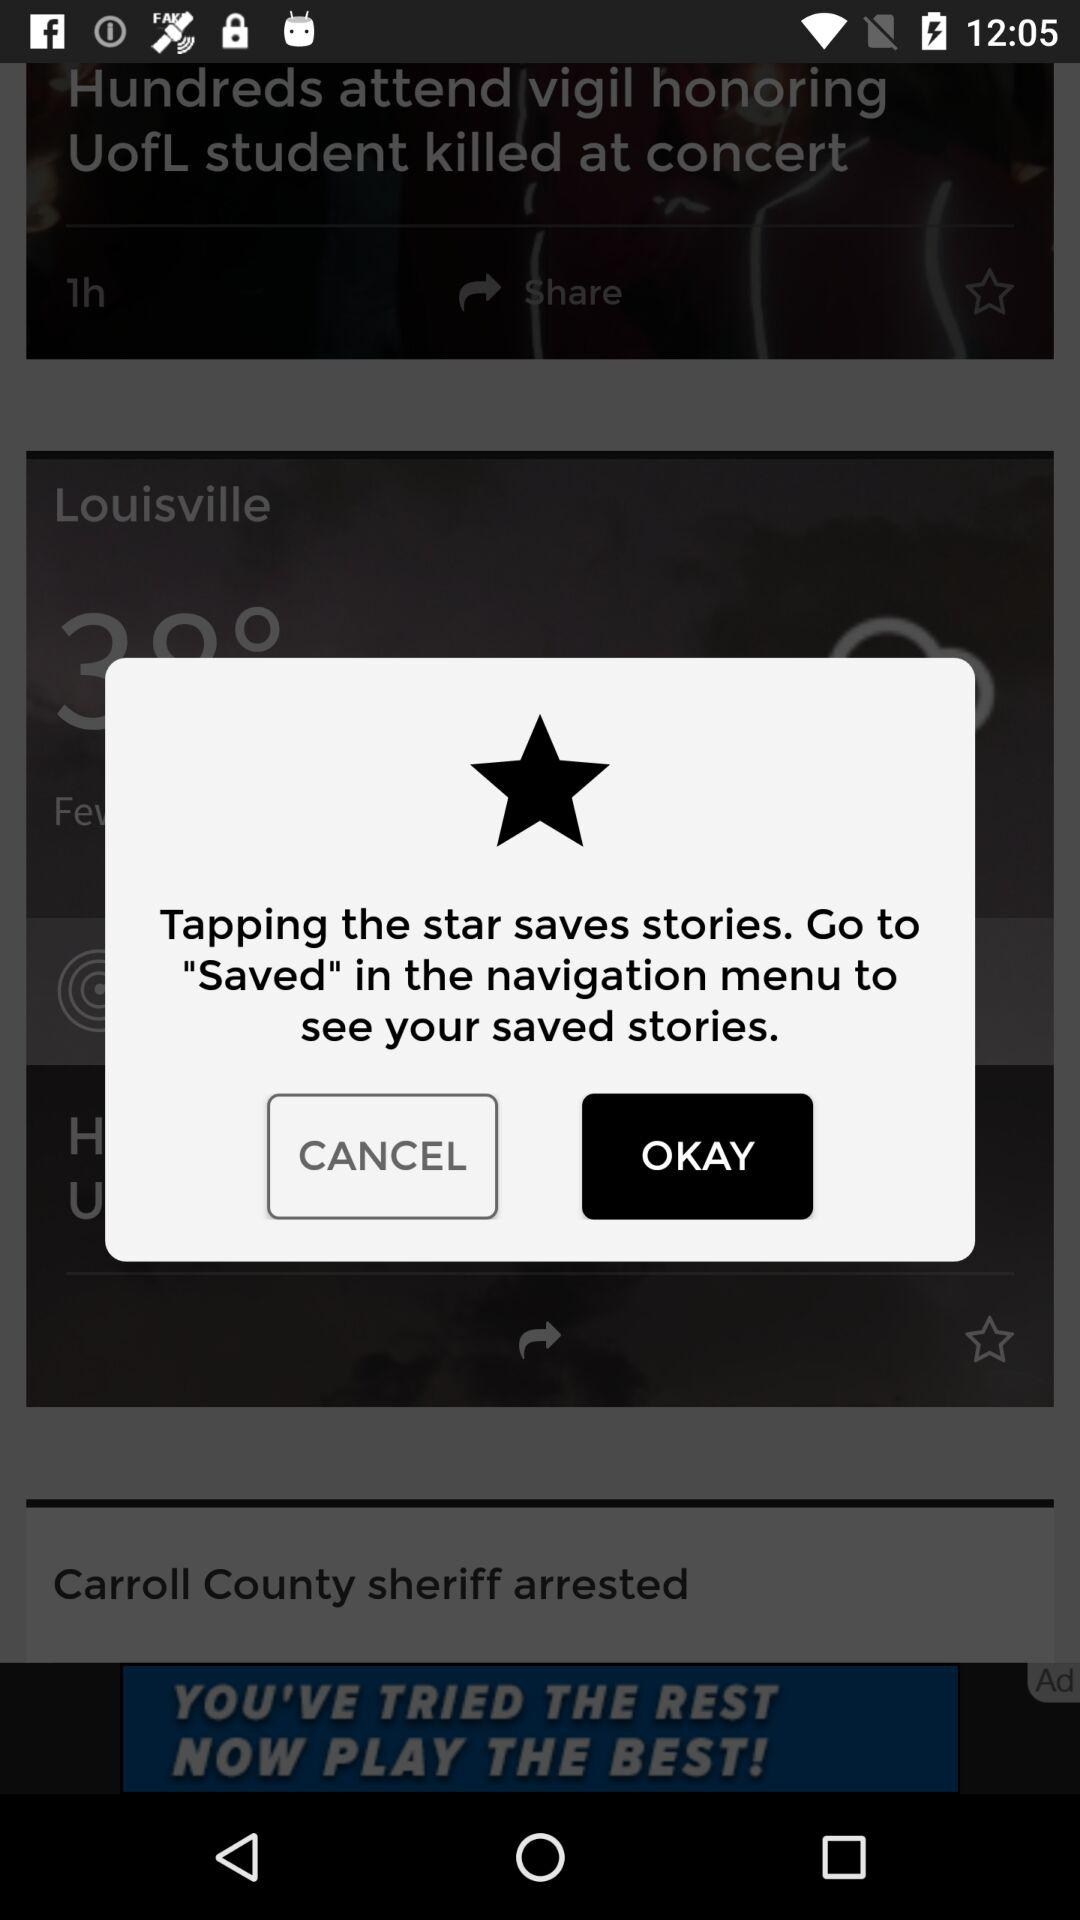How can we save the stories? You can save the stories by tapping the star. 